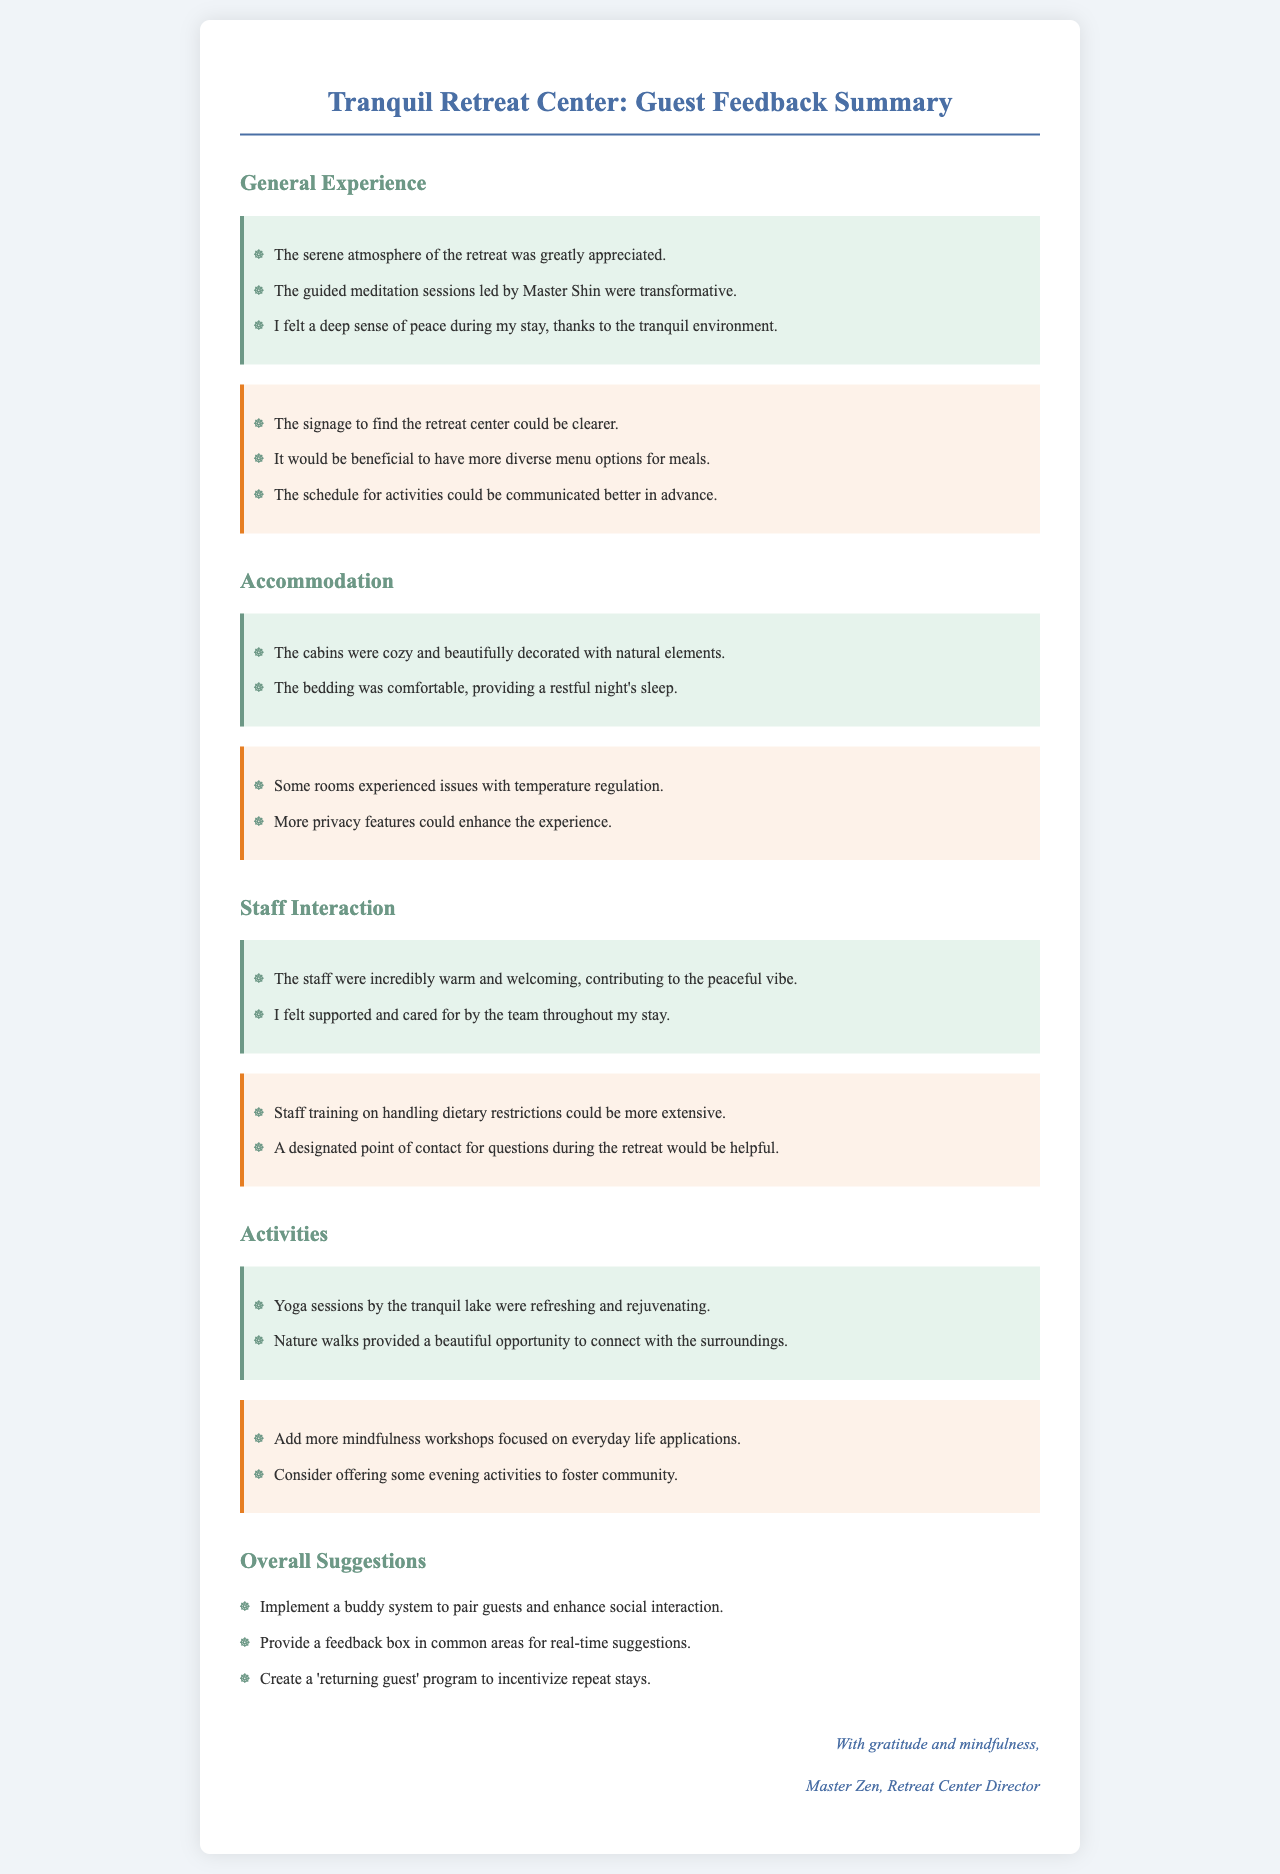What was appreciated about the atmosphere? The feedback section highlights that the serene atmosphere was greatly appreciated by guests.
Answer: serene atmosphere Who led the guided meditation sessions? The document states that the guided meditation sessions were led by Master Shin.
Answer: Master Shin What issue was raised regarding the retreat center's location? Guests mentioned that the signage to find the retreat center could be clearer.
Answer: clearer signage How did guests feel about the staff? The feedback indicates that guests found the staff to be incredibly warm and welcoming.
Answer: warm and welcoming What type of sessions were refreshing by the lake? The document lists that yoga sessions by the tranquil lake were refreshing and rejuvenating.
Answer: yoga sessions What additional activities are suggested for fostering community? The guests suggested considering offering some evening activities to foster community.
Answer: evening activities What system is proposed to enhance guest interactions? The overall suggestions include implementing a buddy system to enhance social interaction among guests.
Answer: buddy system How many improvement suggestions are listed under accommodation? A total of two improvement suggestions are made concerning accommodation in the document.
Answer: two What is one suggested change for handling dietary restrictions? The feedback states that staff training on handling dietary restrictions could be more extensive.
Answer: more extensive training Who is the signatory of the letter? The signatory of the letter is Master Zen, the Retreat Center Director.
Answer: Master Zen 